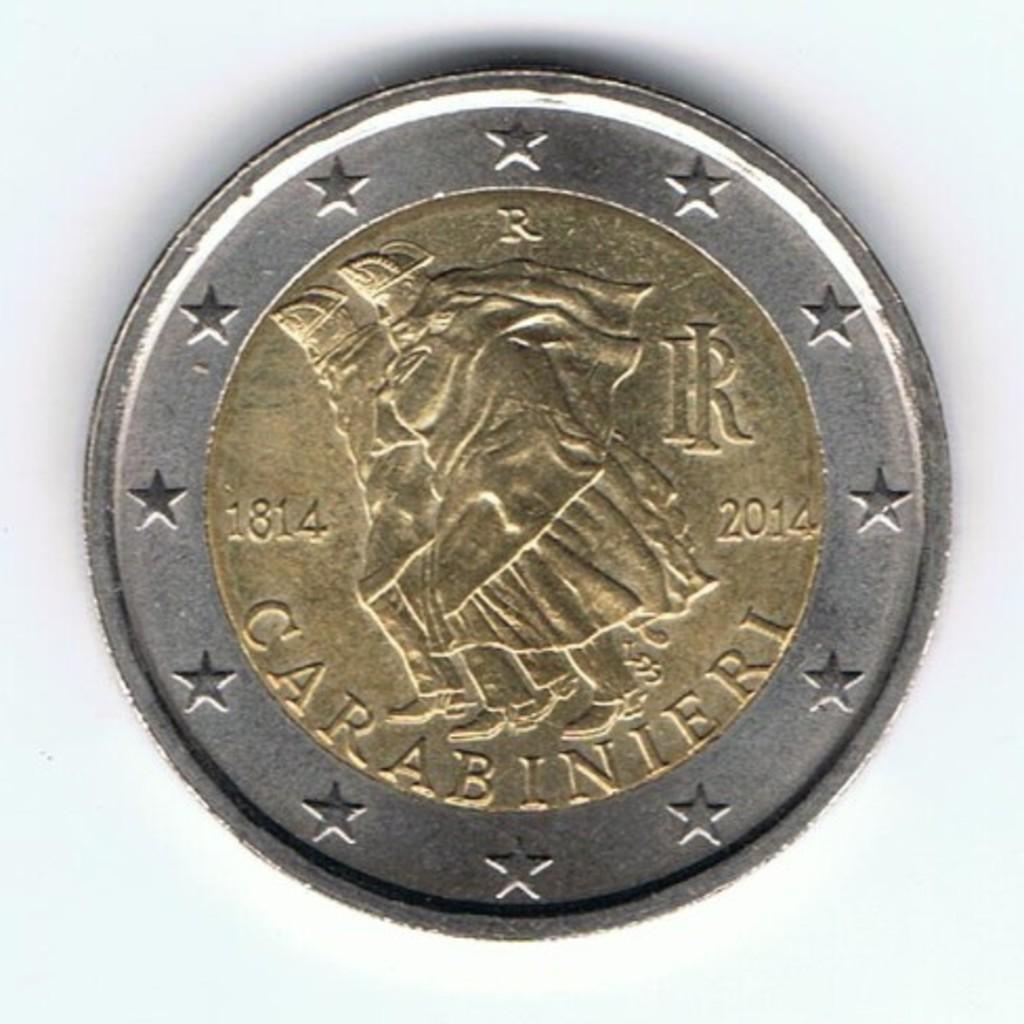What are the two dates on this coin?
Keep it short and to the point. 1814 2014. What word is across the bottom?
Offer a very short reply. Carabinieri. 